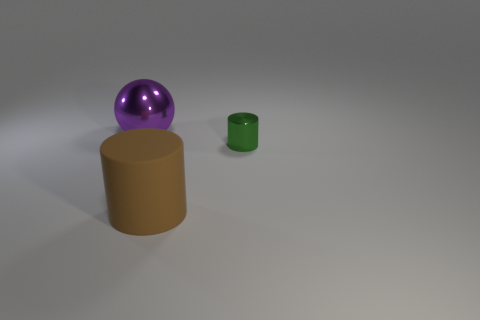Are there any other things that have the same material as the large brown cylinder?
Keep it short and to the point. No. What number of other objects are there of the same color as the small shiny object?
Give a very brief answer. 0. There is a thing that is in front of the shiny object in front of the big thing behind the big matte cylinder; what is its size?
Make the answer very short. Large. Are there any brown matte things in front of the purple thing?
Ensure brevity in your answer.  Yes. Does the purple metal sphere have the same size as the cylinder in front of the small metal object?
Give a very brief answer. Yes. How many other things are there of the same material as the green cylinder?
Offer a terse response. 1. There is a thing that is both behind the big brown thing and in front of the large shiny object; what shape is it?
Give a very brief answer. Cylinder. Do the thing that is on the left side of the big brown rubber cylinder and the cylinder that is to the left of the small object have the same size?
Your answer should be very brief. Yes. What is the shape of the tiny green thing that is the same material as the big purple sphere?
Keep it short and to the point. Cylinder. Is there any other thing that is the same shape as the large metal thing?
Your answer should be compact. No. 